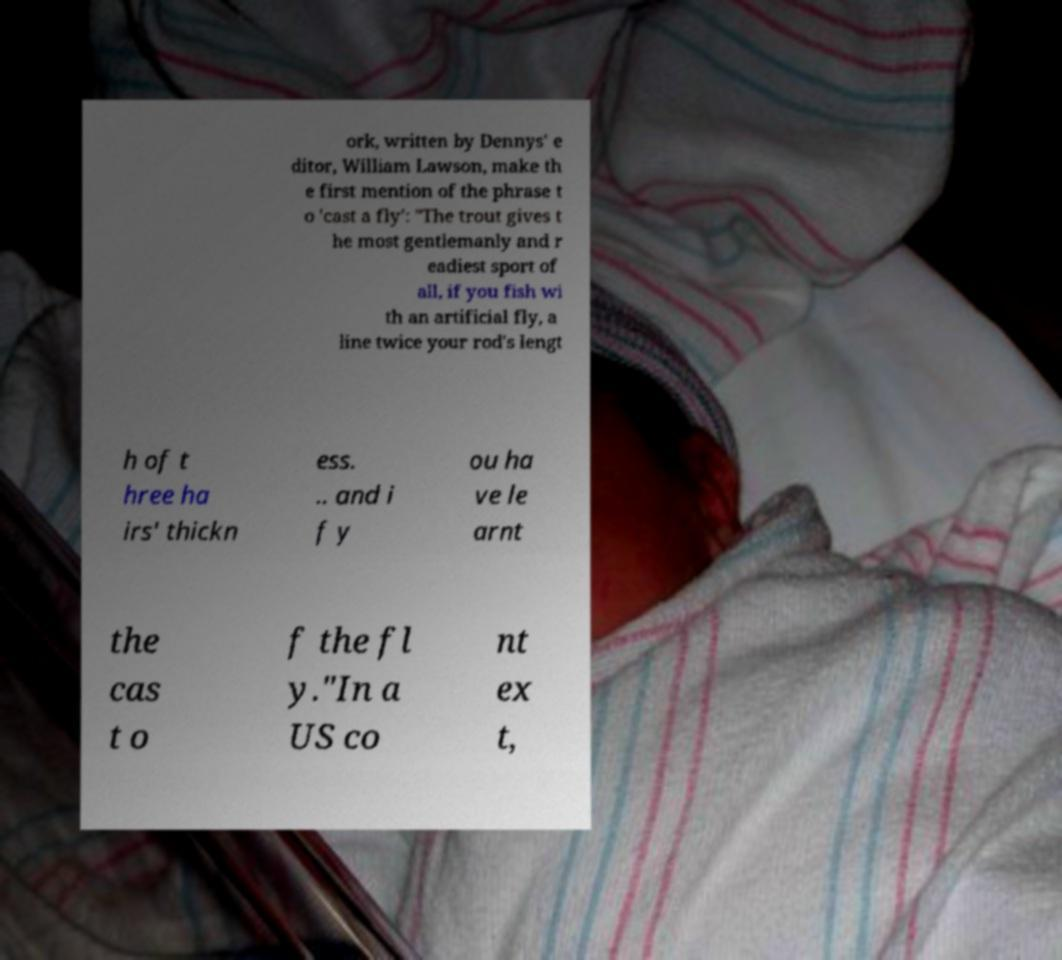I need the written content from this picture converted into text. Can you do that? ork, written by Dennys' e ditor, William Lawson, make th e first mention of the phrase t o 'cast a fly': "The trout gives t he most gentlemanly and r eadiest sport of all, if you fish wi th an artificial fly, a line twice your rod's lengt h of t hree ha irs' thickn ess. .. and i f y ou ha ve le arnt the cas t o f the fl y."In a US co nt ex t, 